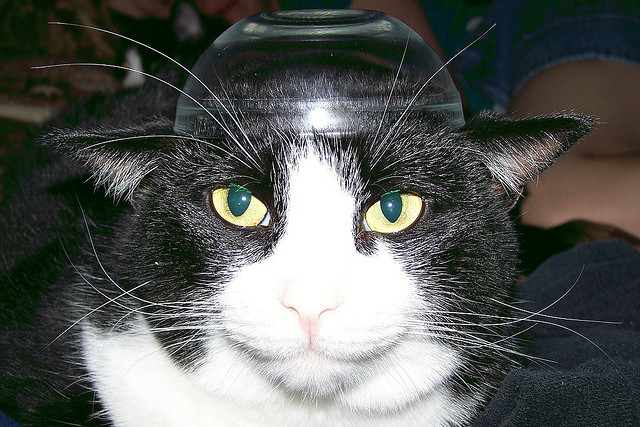<image>How amused does this cat look at wearing a bowl on its head? I don't know how amused the cat looks at wearing a bowl on its head. It can be not amused at all or not very amused. How amused does this cat look at wearing a bowl on its head? The cat doesn't look very amused at wearing a bowl on its head. 